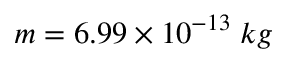Convert formula to latex. <formula><loc_0><loc_0><loc_500><loc_500>m = 6 . 9 9 \times 1 0 ^ { - 1 3 } \, k g</formula> 